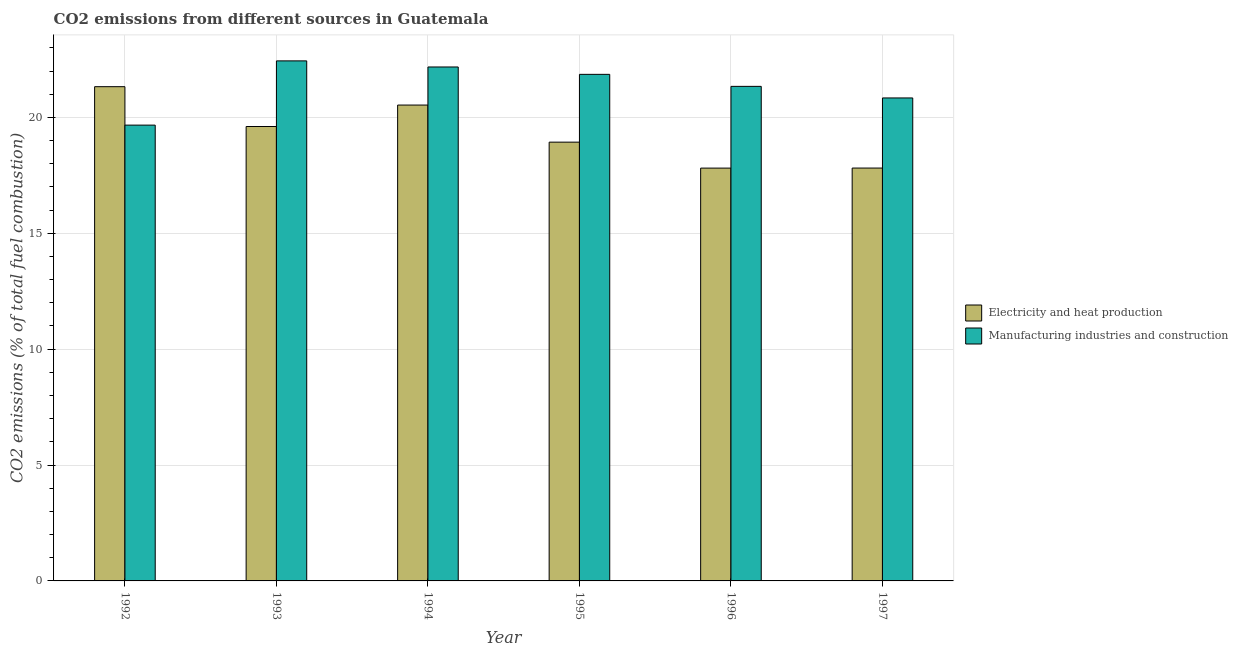How many different coloured bars are there?
Your response must be concise. 2. Are the number of bars per tick equal to the number of legend labels?
Your response must be concise. Yes. In how many cases, is the number of bars for a given year not equal to the number of legend labels?
Your answer should be very brief. 0. What is the co2 emissions due to manufacturing industries in 1992?
Keep it short and to the point. 19.67. Across all years, what is the maximum co2 emissions due to manufacturing industries?
Your answer should be very brief. 22.44. Across all years, what is the minimum co2 emissions due to electricity and heat production?
Provide a short and direct response. 17.81. In which year was the co2 emissions due to electricity and heat production maximum?
Provide a short and direct response. 1992. In which year was the co2 emissions due to electricity and heat production minimum?
Your answer should be compact. 1996. What is the total co2 emissions due to electricity and heat production in the graph?
Offer a very short reply. 116.03. What is the difference between the co2 emissions due to electricity and heat production in 1993 and that in 1995?
Offer a very short reply. 0.67. What is the difference between the co2 emissions due to electricity and heat production in 1996 and the co2 emissions due to manufacturing industries in 1995?
Give a very brief answer. -1.12. What is the average co2 emissions due to electricity and heat production per year?
Provide a succinct answer. 19.34. In the year 1994, what is the difference between the co2 emissions due to manufacturing industries and co2 emissions due to electricity and heat production?
Offer a very short reply. 0. In how many years, is the co2 emissions due to manufacturing industries greater than 9 %?
Offer a very short reply. 6. What is the ratio of the co2 emissions due to manufacturing industries in 1993 to that in 1997?
Your answer should be very brief. 1.08. Is the co2 emissions due to electricity and heat production in 1992 less than that in 1997?
Keep it short and to the point. No. What is the difference between the highest and the second highest co2 emissions due to manufacturing industries?
Your answer should be compact. 0.26. What is the difference between the highest and the lowest co2 emissions due to electricity and heat production?
Your answer should be compact. 3.51. What does the 1st bar from the left in 1996 represents?
Your answer should be very brief. Electricity and heat production. What does the 2nd bar from the right in 1996 represents?
Your answer should be compact. Electricity and heat production. Are all the bars in the graph horizontal?
Your answer should be very brief. No. How many years are there in the graph?
Your answer should be compact. 6. What is the difference between two consecutive major ticks on the Y-axis?
Provide a succinct answer. 5. Where does the legend appear in the graph?
Provide a short and direct response. Center right. How are the legend labels stacked?
Give a very brief answer. Vertical. What is the title of the graph?
Your response must be concise. CO2 emissions from different sources in Guatemala. Does "Sanitation services" appear as one of the legend labels in the graph?
Give a very brief answer. No. What is the label or title of the X-axis?
Provide a succinct answer. Year. What is the label or title of the Y-axis?
Ensure brevity in your answer.  CO2 emissions (% of total fuel combustion). What is the CO2 emissions (% of total fuel combustion) in Electricity and heat production in 1992?
Offer a terse response. 21.33. What is the CO2 emissions (% of total fuel combustion) of Manufacturing industries and construction in 1992?
Offer a very short reply. 19.67. What is the CO2 emissions (% of total fuel combustion) of Electricity and heat production in 1993?
Offer a terse response. 19.61. What is the CO2 emissions (% of total fuel combustion) of Manufacturing industries and construction in 1993?
Provide a short and direct response. 22.44. What is the CO2 emissions (% of total fuel combustion) in Electricity and heat production in 1994?
Your response must be concise. 20.53. What is the CO2 emissions (% of total fuel combustion) in Manufacturing industries and construction in 1994?
Provide a short and direct response. 22.18. What is the CO2 emissions (% of total fuel combustion) in Electricity and heat production in 1995?
Keep it short and to the point. 18.93. What is the CO2 emissions (% of total fuel combustion) of Manufacturing industries and construction in 1995?
Give a very brief answer. 21.86. What is the CO2 emissions (% of total fuel combustion) of Electricity and heat production in 1996?
Provide a succinct answer. 17.81. What is the CO2 emissions (% of total fuel combustion) of Manufacturing industries and construction in 1996?
Your answer should be compact. 21.34. What is the CO2 emissions (% of total fuel combustion) of Electricity and heat production in 1997?
Your answer should be compact. 17.82. What is the CO2 emissions (% of total fuel combustion) of Manufacturing industries and construction in 1997?
Your answer should be very brief. 20.84. Across all years, what is the maximum CO2 emissions (% of total fuel combustion) in Electricity and heat production?
Offer a very short reply. 21.33. Across all years, what is the maximum CO2 emissions (% of total fuel combustion) in Manufacturing industries and construction?
Keep it short and to the point. 22.44. Across all years, what is the minimum CO2 emissions (% of total fuel combustion) in Electricity and heat production?
Your answer should be compact. 17.81. Across all years, what is the minimum CO2 emissions (% of total fuel combustion) of Manufacturing industries and construction?
Your response must be concise. 19.67. What is the total CO2 emissions (% of total fuel combustion) in Electricity and heat production in the graph?
Ensure brevity in your answer.  116.03. What is the total CO2 emissions (% of total fuel combustion) in Manufacturing industries and construction in the graph?
Offer a terse response. 128.32. What is the difference between the CO2 emissions (% of total fuel combustion) in Electricity and heat production in 1992 and that in 1993?
Give a very brief answer. 1.72. What is the difference between the CO2 emissions (% of total fuel combustion) in Manufacturing industries and construction in 1992 and that in 1993?
Provide a short and direct response. -2.77. What is the difference between the CO2 emissions (% of total fuel combustion) in Electricity and heat production in 1992 and that in 1994?
Give a very brief answer. 0.79. What is the difference between the CO2 emissions (% of total fuel combustion) of Manufacturing industries and construction in 1992 and that in 1994?
Your response must be concise. -2.51. What is the difference between the CO2 emissions (% of total fuel combustion) in Electricity and heat production in 1992 and that in 1995?
Make the answer very short. 2.39. What is the difference between the CO2 emissions (% of total fuel combustion) in Manufacturing industries and construction in 1992 and that in 1995?
Your response must be concise. -2.19. What is the difference between the CO2 emissions (% of total fuel combustion) of Electricity and heat production in 1992 and that in 1996?
Give a very brief answer. 3.51. What is the difference between the CO2 emissions (% of total fuel combustion) of Manufacturing industries and construction in 1992 and that in 1996?
Your answer should be compact. -1.67. What is the difference between the CO2 emissions (% of total fuel combustion) of Electricity and heat production in 1992 and that in 1997?
Your answer should be compact. 3.51. What is the difference between the CO2 emissions (% of total fuel combustion) of Manufacturing industries and construction in 1992 and that in 1997?
Ensure brevity in your answer.  -1.17. What is the difference between the CO2 emissions (% of total fuel combustion) of Electricity and heat production in 1993 and that in 1994?
Offer a very short reply. -0.93. What is the difference between the CO2 emissions (% of total fuel combustion) of Manufacturing industries and construction in 1993 and that in 1994?
Give a very brief answer. 0.26. What is the difference between the CO2 emissions (% of total fuel combustion) of Electricity and heat production in 1993 and that in 1995?
Provide a short and direct response. 0.68. What is the difference between the CO2 emissions (% of total fuel combustion) of Manufacturing industries and construction in 1993 and that in 1995?
Your response must be concise. 0.58. What is the difference between the CO2 emissions (% of total fuel combustion) of Electricity and heat production in 1993 and that in 1996?
Provide a succinct answer. 1.79. What is the difference between the CO2 emissions (% of total fuel combustion) in Manufacturing industries and construction in 1993 and that in 1996?
Offer a terse response. 1.1. What is the difference between the CO2 emissions (% of total fuel combustion) of Electricity and heat production in 1993 and that in 1997?
Keep it short and to the point. 1.79. What is the difference between the CO2 emissions (% of total fuel combustion) in Manufacturing industries and construction in 1993 and that in 1997?
Your response must be concise. 1.6. What is the difference between the CO2 emissions (% of total fuel combustion) of Electricity and heat production in 1994 and that in 1995?
Provide a short and direct response. 1.6. What is the difference between the CO2 emissions (% of total fuel combustion) in Manufacturing industries and construction in 1994 and that in 1995?
Provide a short and direct response. 0.32. What is the difference between the CO2 emissions (% of total fuel combustion) of Electricity and heat production in 1994 and that in 1996?
Provide a short and direct response. 2.72. What is the difference between the CO2 emissions (% of total fuel combustion) in Manufacturing industries and construction in 1994 and that in 1996?
Ensure brevity in your answer.  0.84. What is the difference between the CO2 emissions (% of total fuel combustion) of Electricity and heat production in 1994 and that in 1997?
Your answer should be very brief. 2.72. What is the difference between the CO2 emissions (% of total fuel combustion) in Manufacturing industries and construction in 1994 and that in 1997?
Make the answer very short. 1.34. What is the difference between the CO2 emissions (% of total fuel combustion) of Electricity and heat production in 1995 and that in 1996?
Keep it short and to the point. 1.12. What is the difference between the CO2 emissions (% of total fuel combustion) in Manufacturing industries and construction in 1995 and that in 1996?
Provide a succinct answer. 0.52. What is the difference between the CO2 emissions (% of total fuel combustion) of Electricity and heat production in 1995 and that in 1997?
Provide a short and direct response. 1.12. What is the difference between the CO2 emissions (% of total fuel combustion) in Manufacturing industries and construction in 1995 and that in 1997?
Your response must be concise. 1.02. What is the difference between the CO2 emissions (% of total fuel combustion) of Electricity and heat production in 1996 and that in 1997?
Make the answer very short. -0. What is the difference between the CO2 emissions (% of total fuel combustion) in Manufacturing industries and construction in 1996 and that in 1997?
Give a very brief answer. 0.5. What is the difference between the CO2 emissions (% of total fuel combustion) in Electricity and heat production in 1992 and the CO2 emissions (% of total fuel combustion) in Manufacturing industries and construction in 1993?
Offer a very short reply. -1.11. What is the difference between the CO2 emissions (% of total fuel combustion) of Electricity and heat production in 1992 and the CO2 emissions (% of total fuel combustion) of Manufacturing industries and construction in 1994?
Offer a very short reply. -0.85. What is the difference between the CO2 emissions (% of total fuel combustion) in Electricity and heat production in 1992 and the CO2 emissions (% of total fuel combustion) in Manufacturing industries and construction in 1995?
Ensure brevity in your answer.  -0.53. What is the difference between the CO2 emissions (% of total fuel combustion) in Electricity and heat production in 1992 and the CO2 emissions (% of total fuel combustion) in Manufacturing industries and construction in 1996?
Provide a succinct answer. -0.01. What is the difference between the CO2 emissions (% of total fuel combustion) of Electricity and heat production in 1992 and the CO2 emissions (% of total fuel combustion) of Manufacturing industries and construction in 1997?
Offer a very short reply. 0.49. What is the difference between the CO2 emissions (% of total fuel combustion) in Electricity and heat production in 1993 and the CO2 emissions (% of total fuel combustion) in Manufacturing industries and construction in 1994?
Offer a terse response. -2.57. What is the difference between the CO2 emissions (% of total fuel combustion) of Electricity and heat production in 1993 and the CO2 emissions (% of total fuel combustion) of Manufacturing industries and construction in 1995?
Provide a short and direct response. -2.25. What is the difference between the CO2 emissions (% of total fuel combustion) of Electricity and heat production in 1993 and the CO2 emissions (% of total fuel combustion) of Manufacturing industries and construction in 1996?
Ensure brevity in your answer.  -1.73. What is the difference between the CO2 emissions (% of total fuel combustion) of Electricity and heat production in 1993 and the CO2 emissions (% of total fuel combustion) of Manufacturing industries and construction in 1997?
Ensure brevity in your answer.  -1.23. What is the difference between the CO2 emissions (% of total fuel combustion) of Electricity and heat production in 1994 and the CO2 emissions (% of total fuel combustion) of Manufacturing industries and construction in 1995?
Provide a short and direct response. -1.32. What is the difference between the CO2 emissions (% of total fuel combustion) of Electricity and heat production in 1994 and the CO2 emissions (% of total fuel combustion) of Manufacturing industries and construction in 1996?
Offer a very short reply. -0.81. What is the difference between the CO2 emissions (% of total fuel combustion) of Electricity and heat production in 1994 and the CO2 emissions (% of total fuel combustion) of Manufacturing industries and construction in 1997?
Give a very brief answer. -0.31. What is the difference between the CO2 emissions (% of total fuel combustion) in Electricity and heat production in 1995 and the CO2 emissions (% of total fuel combustion) in Manufacturing industries and construction in 1996?
Your answer should be compact. -2.41. What is the difference between the CO2 emissions (% of total fuel combustion) in Electricity and heat production in 1995 and the CO2 emissions (% of total fuel combustion) in Manufacturing industries and construction in 1997?
Provide a succinct answer. -1.91. What is the difference between the CO2 emissions (% of total fuel combustion) in Electricity and heat production in 1996 and the CO2 emissions (% of total fuel combustion) in Manufacturing industries and construction in 1997?
Your response must be concise. -3.03. What is the average CO2 emissions (% of total fuel combustion) of Electricity and heat production per year?
Keep it short and to the point. 19.34. What is the average CO2 emissions (% of total fuel combustion) of Manufacturing industries and construction per year?
Keep it short and to the point. 21.39. In the year 1992, what is the difference between the CO2 emissions (% of total fuel combustion) in Electricity and heat production and CO2 emissions (% of total fuel combustion) in Manufacturing industries and construction?
Your answer should be compact. 1.66. In the year 1993, what is the difference between the CO2 emissions (% of total fuel combustion) in Electricity and heat production and CO2 emissions (% of total fuel combustion) in Manufacturing industries and construction?
Ensure brevity in your answer.  -2.83. In the year 1994, what is the difference between the CO2 emissions (% of total fuel combustion) in Electricity and heat production and CO2 emissions (% of total fuel combustion) in Manufacturing industries and construction?
Your answer should be very brief. -1.64. In the year 1995, what is the difference between the CO2 emissions (% of total fuel combustion) in Electricity and heat production and CO2 emissions (% of total fuel combustion) in Manufacturing industries and construction?
Ensure brevity in your answer.  -2.93. In the year 1996, what is the difference between the CO2 emissions (% of total fuel combustion) of Electricity and heat production and CO2 emissions (% of total fuel combustion) of Manufacturing industries and construction?
Your answer should be very brief. -3.53. In the year 1997, what is the difference between the CO2 emissions (% of total fuel combustion) in Electricity and heat production and CO2 emissions (% of total fuel combustion) in Manufacturing industries and construction?
Offer a terse response. -3.03. What is the ratio of the CO2 emissions (% of total fuel combustion) in Electricity and heat production in 1992 to that in 1993?
Your answer should be compact. 1.09. What is the ratio of the CO2 emissions (% of total fuel combustion) of Manufacturing industries and construction in 1992 to that in 1993?
Offer a very short reply. 0.88. What is the ratio of the CO2 emissions (% of total fuel combustion) in Electricity and heat production in 1992 to that in 1994?
Give a very brief answer. 1.04. What is the ratio of the CO2 emissions (% of total fuel combustion) of Manufacturing industries and construction in 1992 to that in 1994?
Provide a short and direct response. 0.89. What is the ratio of the CO2 emissions (% of total fuel combustion) of Electricity and heat production in 1992 to that in 1995?
Give a very brief answer. 1.13. What is the ratio of the CO2 emissions (% of total fuel combustion) of Manufacturing industries and construction in 1992 to that in 1995?
Your answer should be very brief. 0.9. What is the ratio of the CO2 emissions (% of total fuel combustion) of Electricity and heat production in 1992 to that in 1996?
Provide a short and direct response. 1.2. What is the ratio of the CO2 emissions (% of total fuel combustion) in Manufacturing industries and construction in 1992 to that in 1996?
Provide a short and direct response. 0.92. What is the ratio of the CO2 emissions (% of total fuel combustion) of Electricity and heat production in 1992 to that in 1997?
Your answer should be very brief. 1.2. What is the ratio of the CO2 emissions (% of total fuel combustion) in Manufacturing industries and construction in 1992 to that in 1997?
Keep it short and to the point. 0.94. What is the ratio of the CO2 emissions (% of total fuel combustion) of Electricity and heat production in 1993 to that in 1994?
Provide a succinct answer. 0.95. What is the ratio of the CO2 emissions (% of total fuel combustion) of Manufacturing industries and construction in 1993 to that in 1994?
Provide a succinct answer. 1.01. What is the ratio of the CO2 emissions (% of total fuel combustion) of Electricity and heat production in 1993 to that in 1995?
Make the answer very short. 1.04. What is the ratio of the CO2 emissions (% of total fuel combustion) of Manufacturing industries and construction in 1993 to that in 1995?
Offer a terse response. 1.03. What is the ratio of the CO2 emissions (% of total fuel combustion) in Electricity and heat production in 1993 to that in 1996?
Keep it short and to the point. 1.1. What is the ratio of the CO2 emissions (% of total fuel combustion) of Manufacturing industries and construction in 1993 to that in 1996?
Give a very brief answer. 1.05. What is the ratio of the CO2 emissions (% of total fuel combustion) in Electricity and heat production in 1993 to that in 1997?
Offer a very short reply. 1.1. What is the ratio of the CO2 emissions (% of total fuel combustion) in Manufacturing industries and construction in 1993 to that in 1997?
Provide a succinct answer. 1.08. What is the ratio of the CO2 emissions (% of total fuel combustion) of Electricity and heat production in 1994 to that in 1995?
Provide a succinct answer. 1.08. What is the ratio of the CO2 emissions (% of total fuel combustion) of Manufacturing industries and construction in 1994 to that in 1995?
Provide a succinct answer. 1.01. What is the ratio of the CO2 emissions (% of total fuel combustion) of Electricity and heat production in 1994 to that in 1996?
Your answer should be compact. 1.15. What is the ratio of the CO2 emissions (% of total fuel combustion) of Manufacturing industries and construction in 1994 to that in 1996?
Ensure brevity in your answer.  1.04. What is the ratio of the CO2 emissions (% of total fuel combustion) in Electricity and heat production in 1994 to that in 1997?
Offer a very short reply. 1.15. What is the ratio of the CO2 emissions (% of total fuel combustion) of Manufacturing industries and construction in 1994 to that in 1997?
Keep it short and to the point. 1.06. What is the ratio of the CO2 emissions (% of total fuel combustion) in Electricity and heat production in 1995 to that in 1996?
Give a very brief answer. 1.06. What is the ratio of the CO2 emissions (% of total fuel combustion) of Manufacturing industries and construction in 1995 to that in 1996?
Your answer should be compact. 1.02. What is the ratio of the CO2 emissions (% of total fuel combustion) of Electricity and heat production in 1995 to that in 1997?
Offer a very short reply. 1.06. What is the ratio of the CO2 emissions (% of total fuel combustion) of Manufacturing industries and construction in 1995 to that in 1997?
Offer a very short reply. 1.05. What is the ratio of the CO2 emissions (% of total fuel combustion) of Electricity and heat production in 1996 to that in 1997?
Your answer should be very brief. 1. What is the difference between the highest and the second highest CO2 emissions (% of total fuel combustion) of Electricity and heat production?
Your answer should be very brief. 0.79. What is the difference between the highest and the second highest CO2 emissions (% of total fuel combustion) of Manufacturing industries and construction?
Give a very brief answer. 0.26. What is the difference between the highest and the lowest CO2 emissions (% of total fuel combustion) in Electricity and heat production?
Your answer should be compact. 3.51. What is the difference between the highest and the lowest CO2 emissions (% of total fuel combustion) in Manufacturing industries and construction?
Provide a succinct answer. 2.77. 